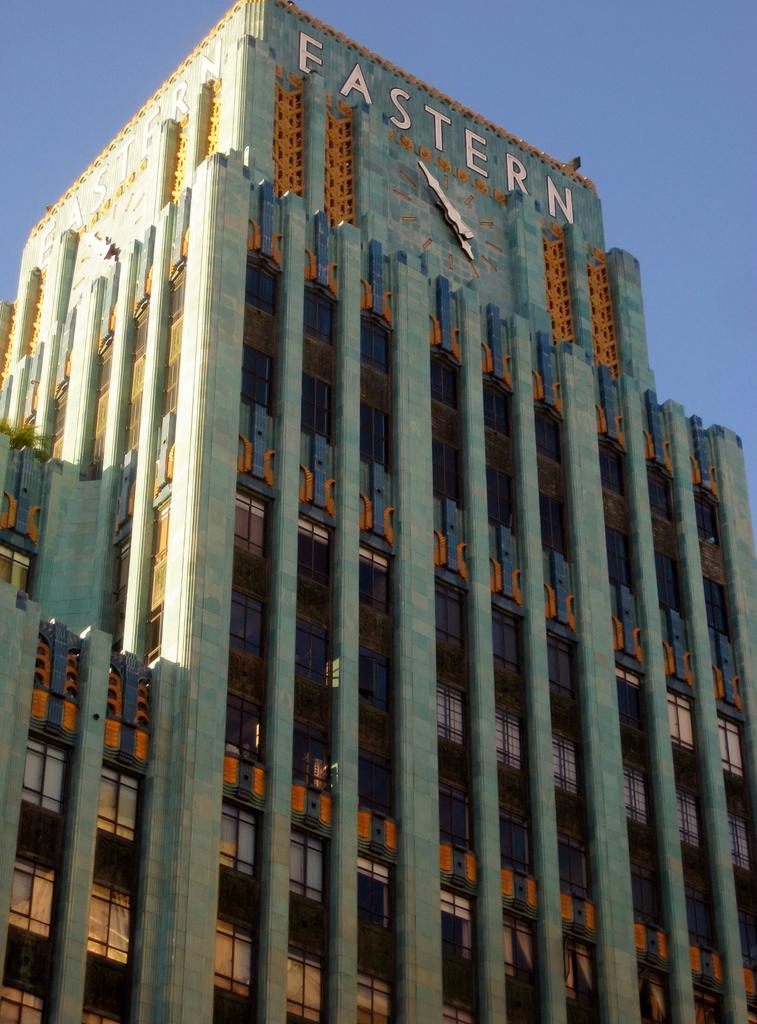What type of structure is present in the image? There is a building in the image. What features can be observed on the building? The building has windows, a signboard, and a clock. What can be seen in the background of the image? The sky is visible in the background of the image. What type of boot is hanging from the clock on the building? There is no boot present in the image; the clock is the only item mentioned on the building. 